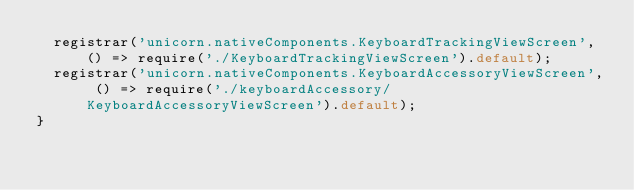Convert code to text. <code><loc_0><loc_0><loc_500><loc_500><_JavaScript_>  registrar('unicorn.nativeComponents.KeyboardTrackingViewScreen', () => require('./KeyboardTrackingViewScreen').default);
  registrar('unicorn.nativeComponents.KeyboardAccessoryViewScreen', () => require('./keyboardAccessory/KeyboardAccessoryViewScreen').default);
}
</code> 